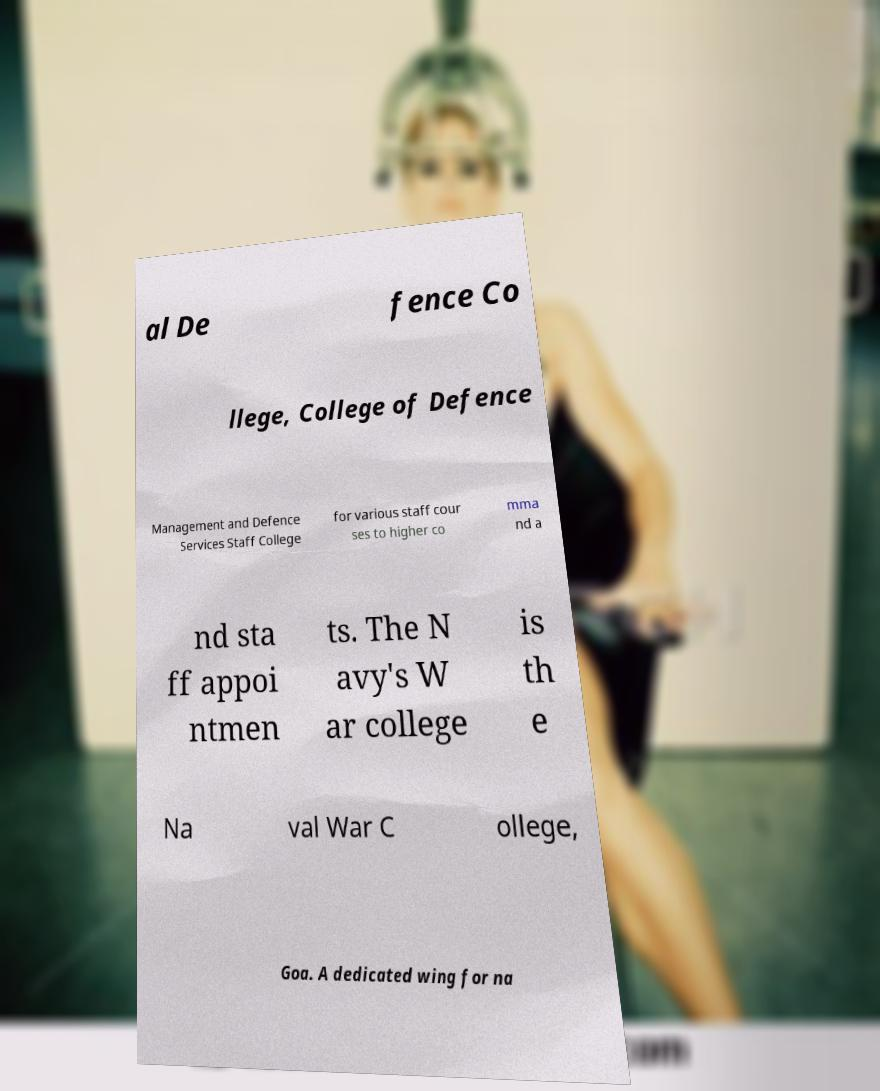What messages or text are displayed in this image? I need them in a readable, typed format. al De fence Co llege, College of Defence Management and Defence Services Staff College for various staff cour ses to higher co mma nd a nd sta ff appoi ntmen ts. The N avy's W ar college is th e Na val War C ollege, Goa. A dedicated wing for na 